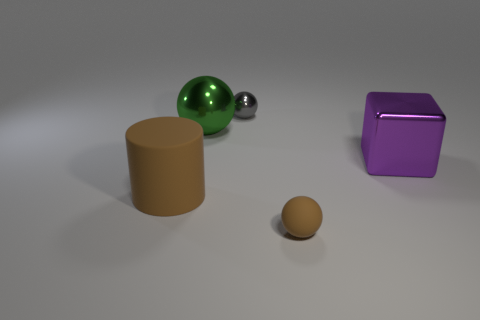How many large metal things are right of the metal ball in front of the small thing that is on the left side of the small brown rubber ball?
Provide a succinct answer. 1. What number of matte things are in front of the large brown cylinder?
Ensure brevity in your answer.  1. There is a sphere left of the small sphere that is behind the purple object; what color is it?
Your response must be concise. Green. How many other objects are the same material as the brown cylinder?
Provide a short and direct response. 1. Are there an equal number of small matte balls that are to the right of the large green ball and brown matte cylinders?
Make the answer very short. Yes. There is a brown thing right of the tiny thing that is to the left of the brown object that is to the right of the small gray metallic sphere; what is it made of?
Provide a succinct answer. Rubber. What is the color of the large object left of the big green sphere?
Ensure brevity in your answer.  Brown. Is there anything else that has the same shape as the tiny brown object?
Offer a terse response. Yes. There is a brown object that is left of the small thing that is to the left of the brown sphere; what is its size?
Provide a succinct answer. Large. Are there the same number of metal blocks to the left of the small gray sphere and large rubber objects that are right of the purple block?
Keep it short and to the point. Yes. 